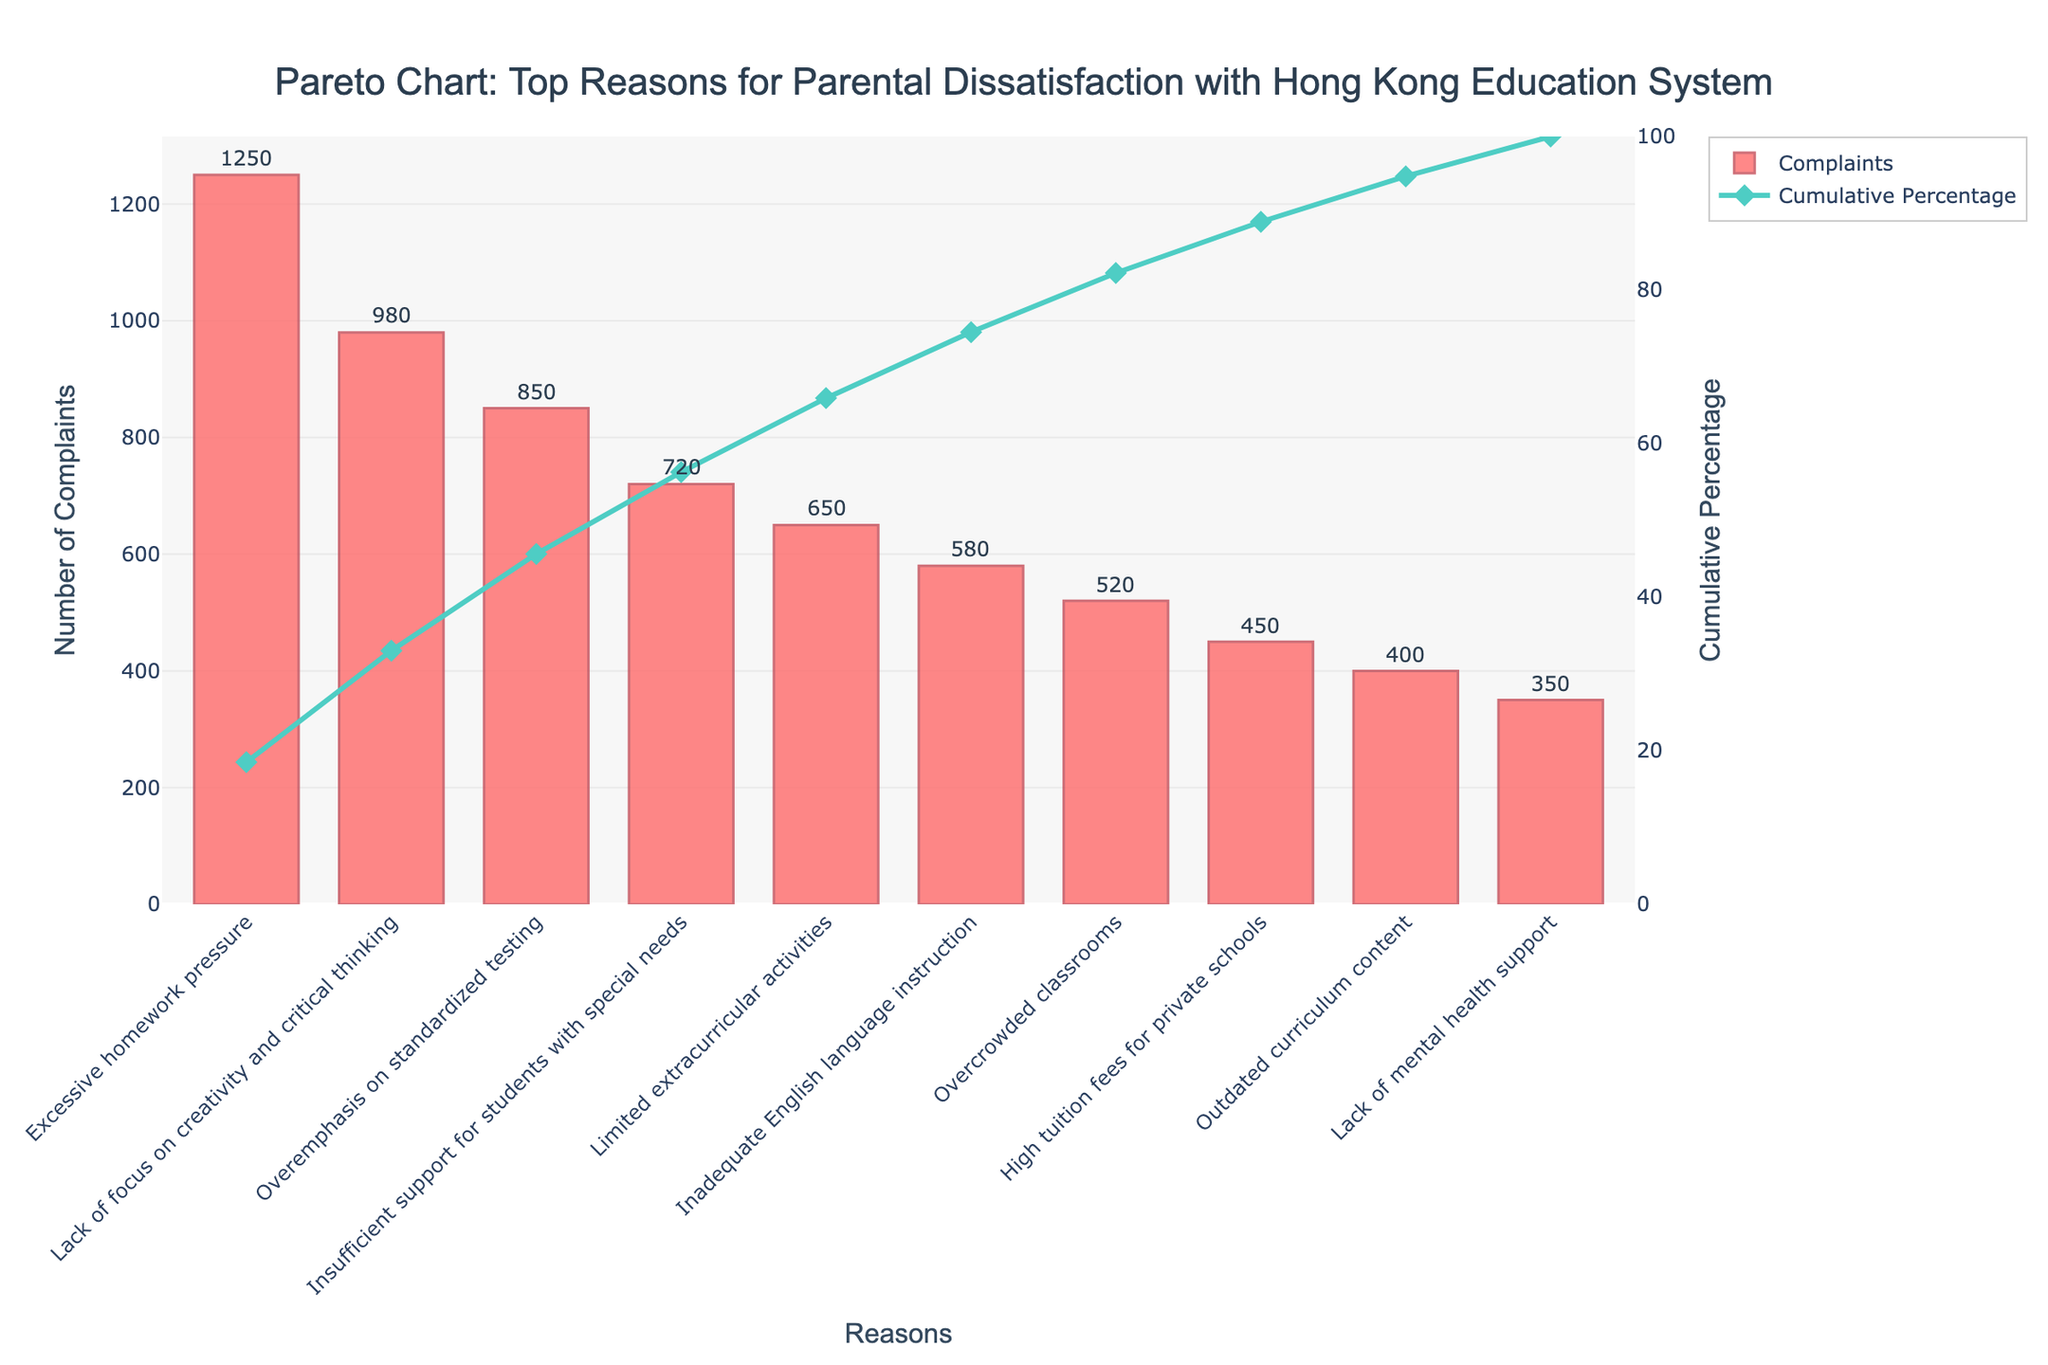What is the title of the chart? The title is usually displayed at the top of the chart to give an overview of what the chart represents. Here, the title is clearly stated in the center.
Answer: Pareto Chart: Top Reasons for Parental Dissatisfaction with Hong Kong Education System What are the two axes titles, and what do they represent? The x-axis represents the different reasons for parental dissatisfaction, and the y-axis (left) represents the number of complaints, while the y-axis (right) represents the cumulative percentage.
Answer: The x-axis is "Reasons," the y-axis (left) is "Number of Complaints," and the y-axis (right) is "Cumulative Percentage." Which reason received the highest number of complaints? The top reason is usually the first bar on the left. The height of this bar indicates the highest number of complaints.
Answer: Excessive homework pressure What is the cumulative percentage for the top three reasons? Sum the cumulative percentages of the first three bars to understand the combined significance of these reasons. The respective percentages are directly labeled or indicated by the trend line.
Answer: 53.33% What color represents the bar chart, and what color represents the cumulative percentage line? The color of the bars and the line can be identified easily through visual observation. Bars are typically highlighted to stand out from the lines.
Answer: Bars are light red, and the cumulative percentage line is teal Which reason has the smallest difference in complaints compared to "Lack of focus on creativity and critical thinking"? Compare the number of complaints for "Lack of focus on creativity and critical thinking" to the adjacent or similar values to find the smallest difference.
Answer: Overemphasis on standardized testing (130 complaints difference) How much more frequent are complaints about "Excessive homework pressure" compared to "Outdated curriculum content"? To find this, subtract the complaints for "Outdated curriculum content" from "Excessive homework pressure."
Answer: 850 How many complaints cumulatively account for 50% of the reasons? Identify the point on the cumulative percentage line closest to 50%, then check the corresponding value on the y-axis for complaints.
Answer: Three reasons What cumulative percentage does "Inadequate English language instruction" approximately contribute to? Locate "Inadequate English language instruction" on the x-axis and trace to the cumulative percentage line to find the approximate value.
Answer: Approximately 81.55% How do the total complaints for "Lack of mental health support" compare with "High tuition fees for private schools"? Directly compare the heights of the bars representing these two reasons.
Answer: Lack of mental health support has 100 fewer complaints 